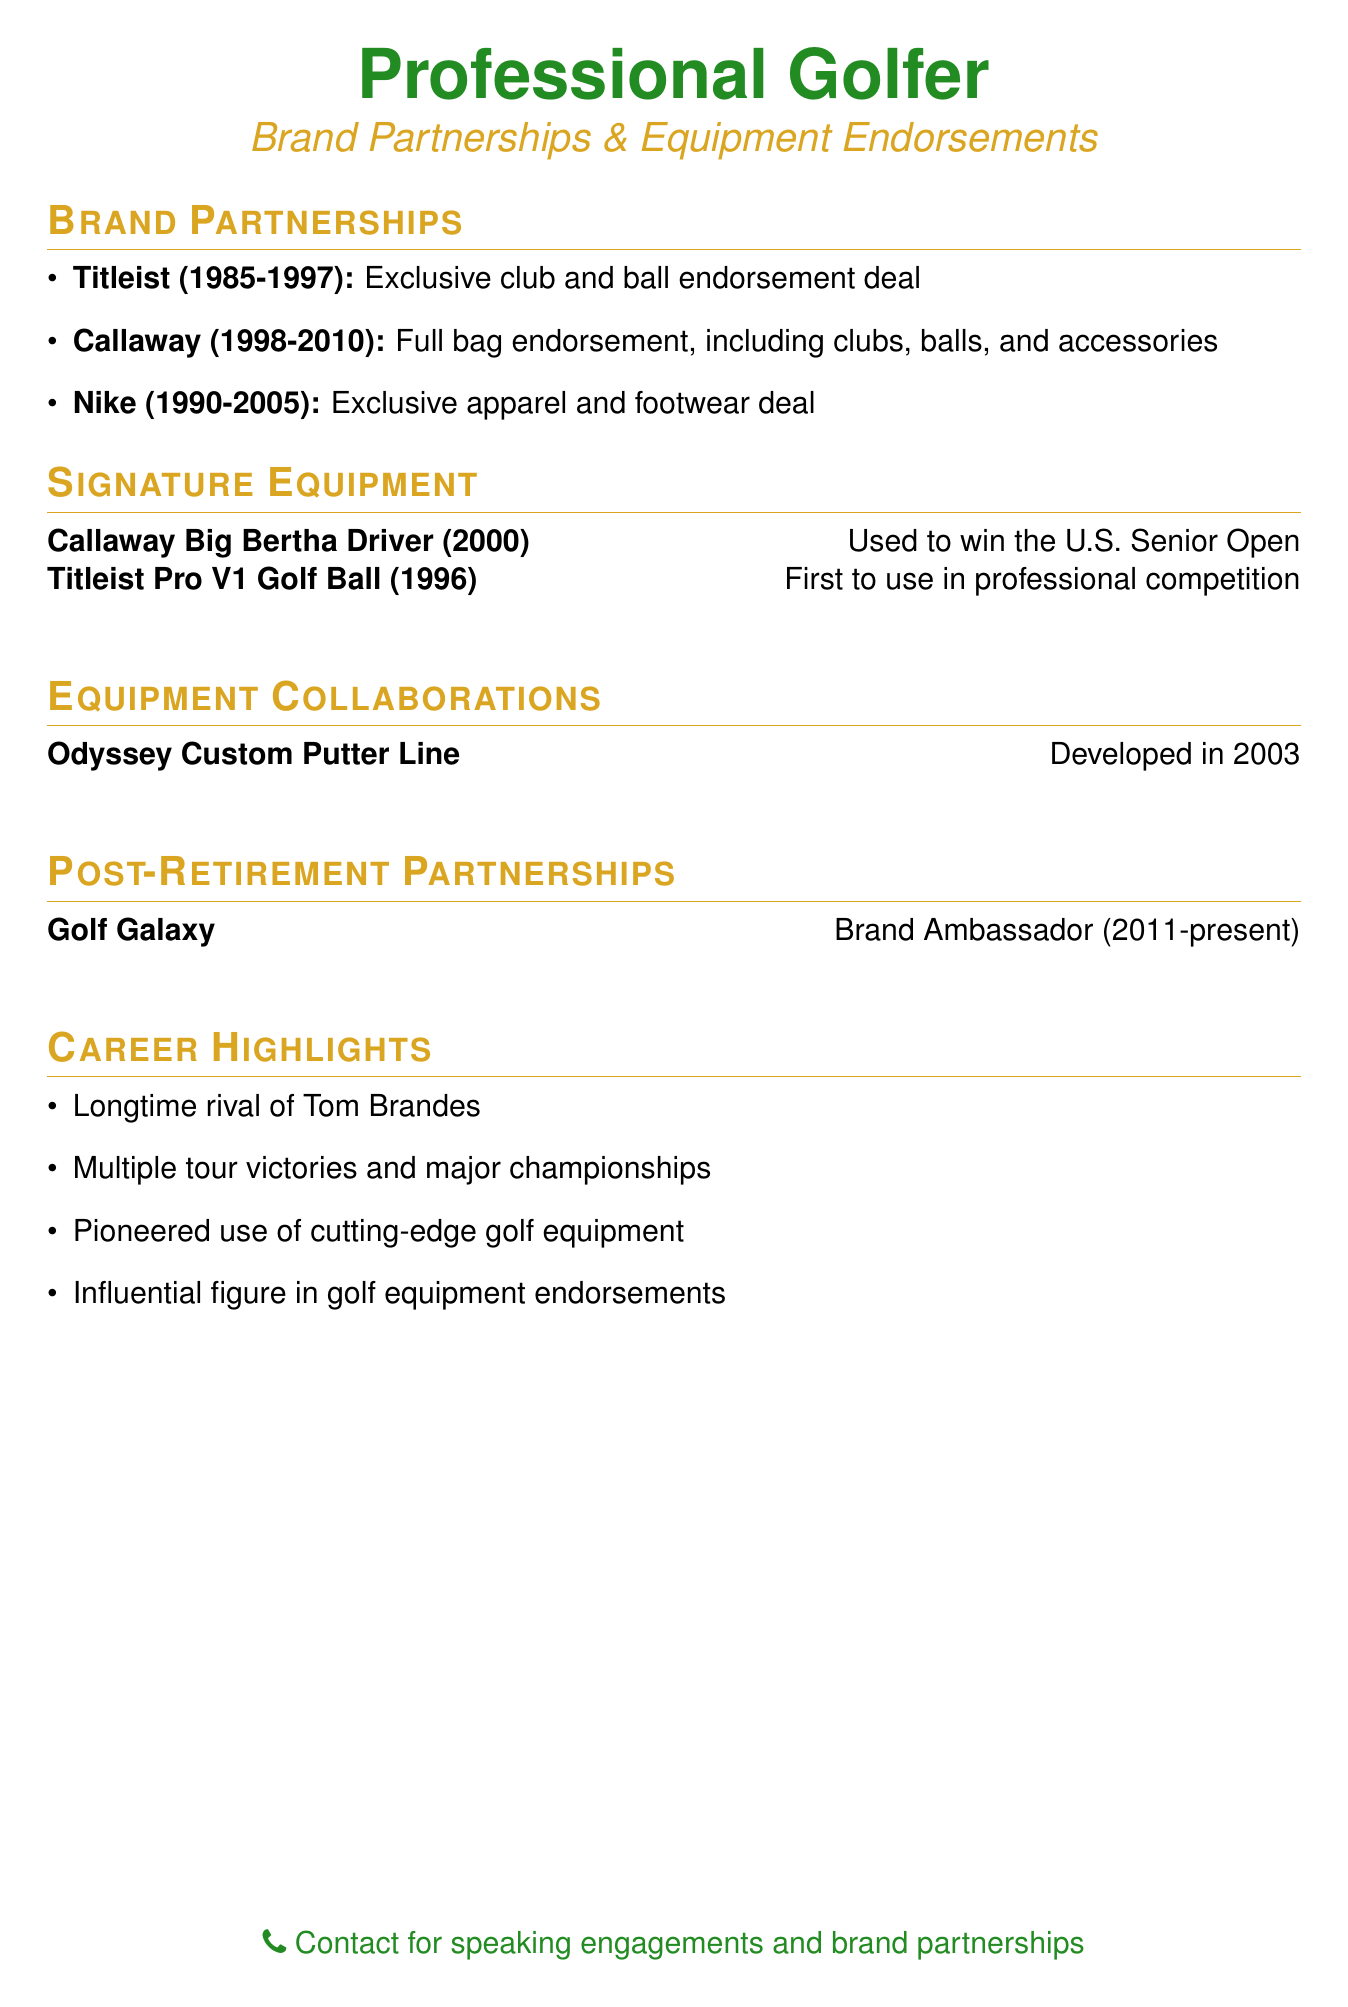What brand did you endorse from 1985 to 1997? The document states you had an exclusive club and ball endorsement deal with Titleist during this time.
Answer: Titleist When did the partnership with Callaway start? The partnership with Callaway started in 1998, as indicated in the document.
Answer: 1998 What year did you first use the Titleist Pro V1 Golf Ball in competition? The document mentions that you were the first to use the Titleist Pro V1 Golf Ball in professional competition in 1996.
Answer: 1996 What is the custom product line developed with Odyssey? The document specifies that the product line developed with Odyssey was a custom putter line in 2003.
Answer: Custom putter line What is your role with Golf Galaxy since 2011? According to the document, you have held the role of Brand Ambassador with Golf Galaxy since 2011.
Answer: Brand Ambassador Which brand provided you exclusive apparel and footwear from 1990 to 2005? The document indicates that Nike provided exclusive apparel and footwear during this period.
Answer: Nike How many years did your partnership with Callaway last? The document states that the partnership with Callaway lasted from 1998 to 2010, which is a total of 12 years.
Answer: 12 years What achievement is linked to the Callaway Big Bertha Driver? The document mentions that the Callaway Big Bertha Driver was used to win the U.S. Senior Open.
Answer: Used to win the U.S. Senior Open What duration does the Nike sponsorship cover? The document specifies that the sponsorship with Nike lasted from 1990 to 2005, which is 15 years.
Answer: 15 years 